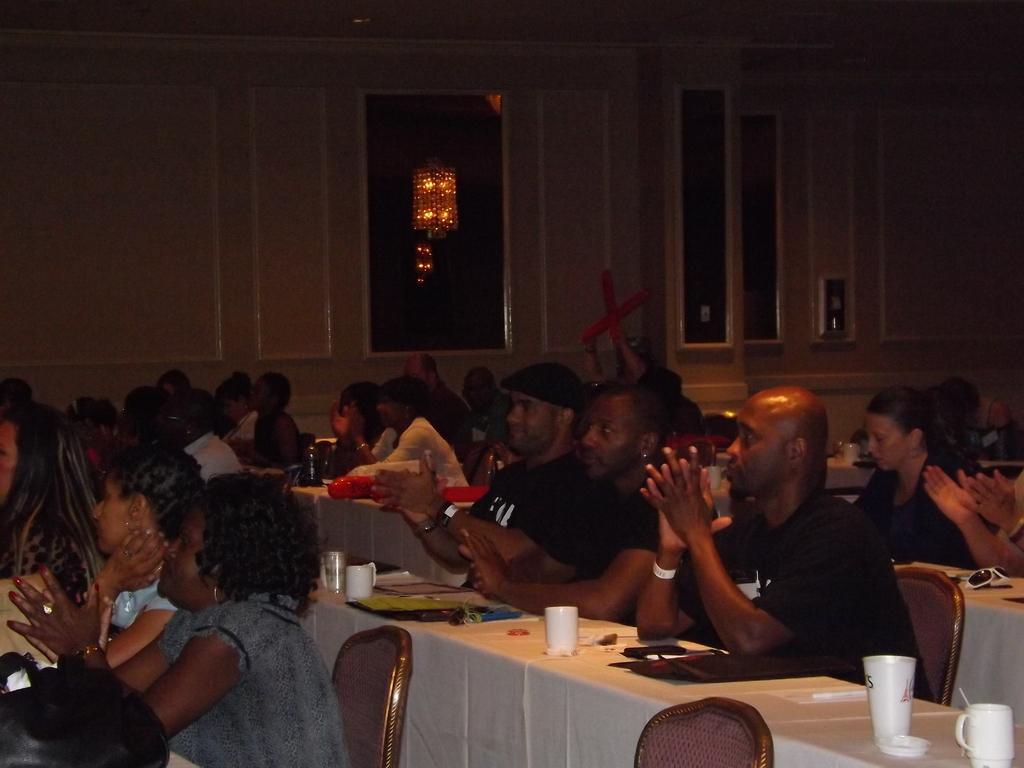Could you give a brief overview of what you see in this image? There are many persons sitting and clapping. And there is a table and on this table there are cups. And behind the table there is one table and there is a goggles. In the background there is a wall. There is a light. 